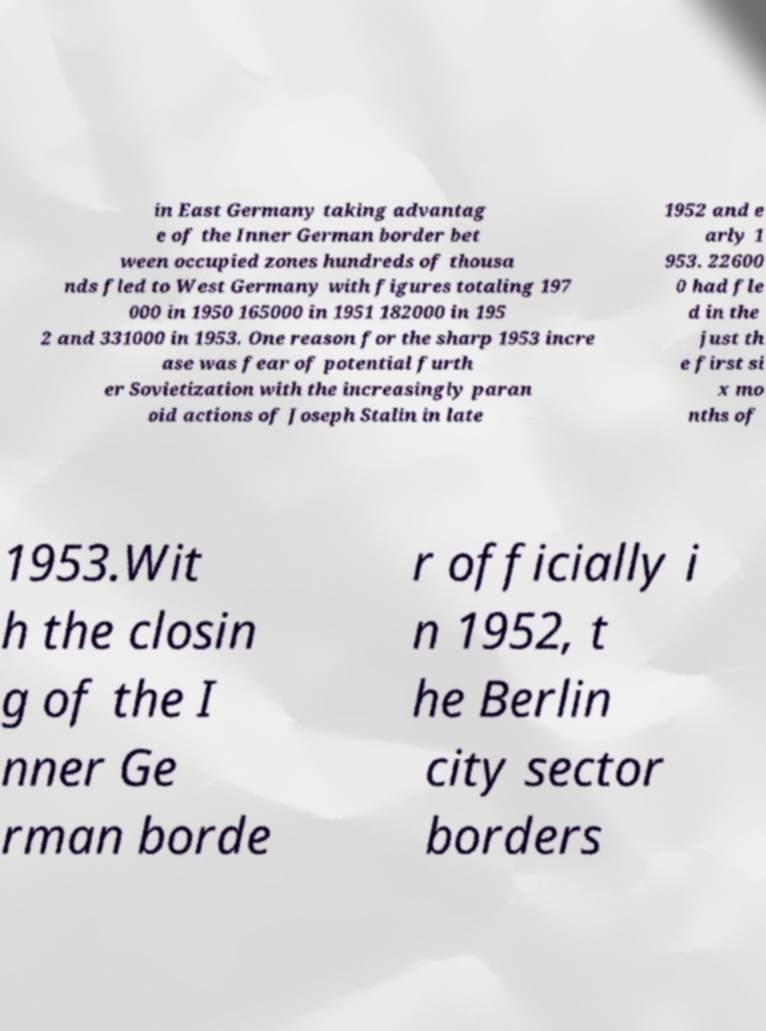Please read and relay the text visible in this image. What does it say? in East Germany taking advantag e of the Inner German border bet ween occupied zones hundreds of thousa nds fled to West Germany with figures totaling 197 000 in 1950 165000 in 1951 182000 in 195 2 and 331000 in 1953. One reason for the sharp 1953 incre ase was fear of potential furth er Sovietization with the increasingly paran oid actions of Joseph Stalin in late 1952 and e arly 1 953. 22600 0 had fle d in the just th e first si x mo nths of 1953.Wit h the closin g of the I nner Ge rman borde r officially i n 1952, t he Berlin city sector borders 